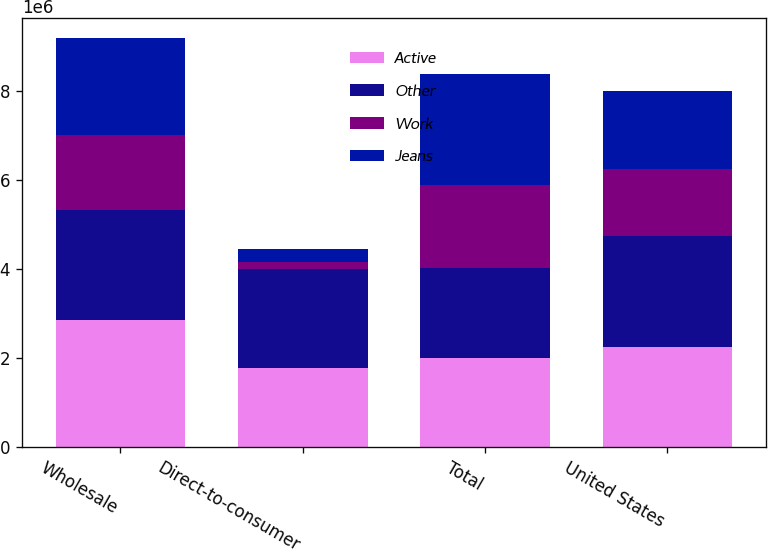<chart> <loc_0><loc_0><loc_500><loc_500><stacked_bar_chart><ecel><fcel>Wholesale<fcel>Direct-to-consumer<fcel>Total<fcel>United States<nl><fcel>Active<fcel>2.86563e+06<fcel>1.77058e+06<fcel>2.01555e+06<fcel>2.24671e+06<nl><fcel>Other<fcel>2.46069e+06<fcel>2.23405e+06<fcel>2.01555e+06<fcel>2.49939e+06<nl><fcel>Work<fcel>1.67847e+06<fcel>160970<fcel>1.86202e+06<fcel>1.49255e+06<nl><fcel>Jeans<fcel>2.16909e+06<fcel>289196<fcel>2.49177e+06<fcel>1.76358e+06<nl></chart> 